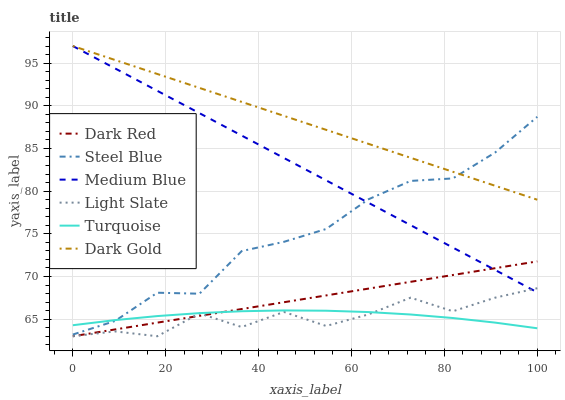Does Dark Gold have the minimum area under the curve?
Answer yes or no. No. Does Light Slate have the maximum area under the curve?
Answer yes or no. No. Is Light Slate the smoothest?
Answer yes or no. No. Is Dark Gold the roughest?
Answer yes or no. No. Does Dark Gold have the lowest value?
Answer yes or no. No. Does Light Slate have the highest value?
Answer yes or no. No. Is Turquoise less than Dark Gold?
Answer yes or no. Yes. Is Dark Gold greater than Turquoise?
Answer yes or no. Yes. Does Turquoise intersect Dark Gold?
Answer yes or no. No. 